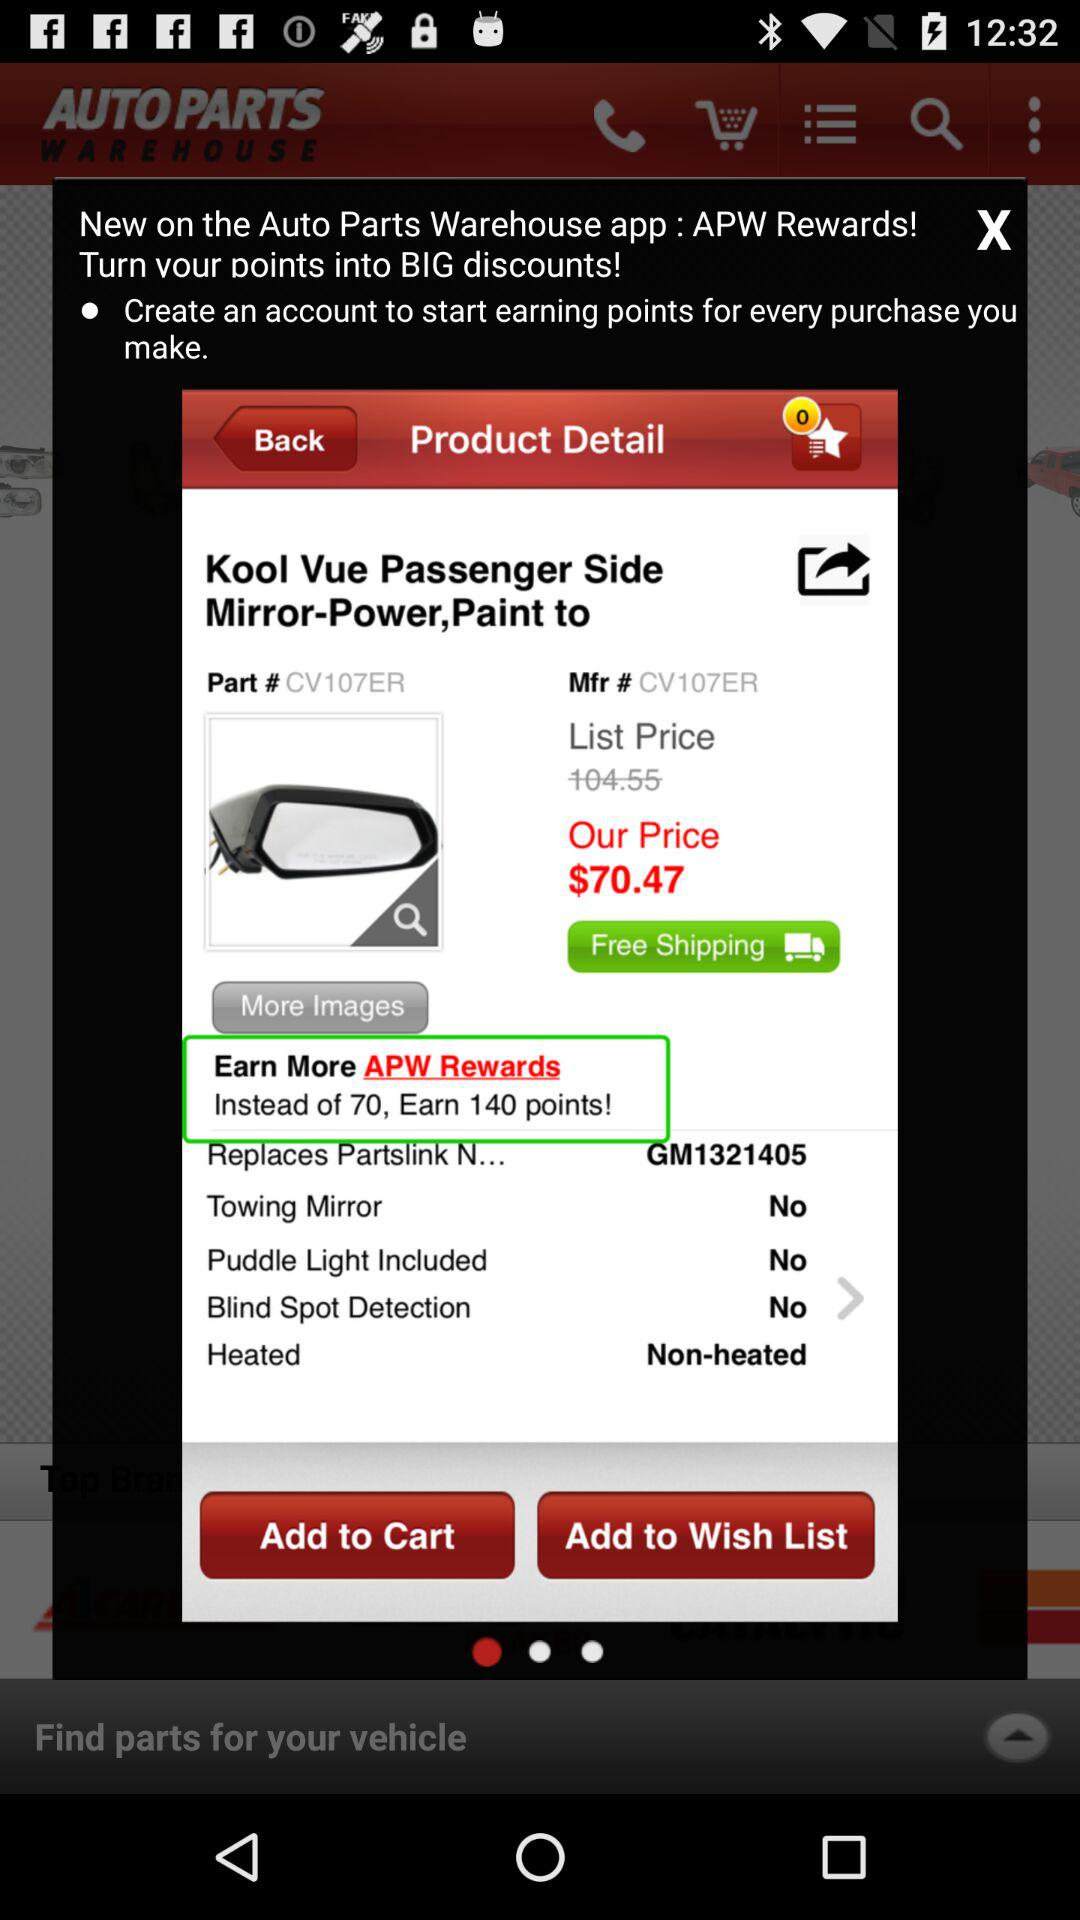How much is the price of the product after the discount?
Answer the question using a single word or phrase. $70.47 